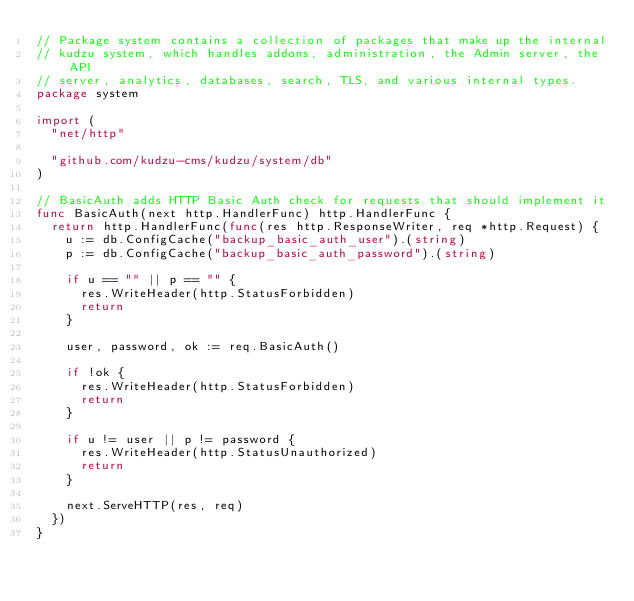Convert code to text. <code><loc_0><loc_0><loc_500><loc_500><_Go_>// Package system contains a collection of packages that make up the internal
// kudzu system, which handles addons, administration, the Admin server, the API
// server, analytics, databases, search, TLS, and various internal types.
package system

import (
	"net/http"

	"github.com/kudzu-cms/kudzu/system/db"
)

// BasicAuth adds HTTP Basic Auth check for requests that should implement it
func BasicAuth(next http.HandlerFunc) http.HandlerFunc {
	return http.HandlerFunc(func(res http.ResponseWriter, req *http.Request) {
		u := db.ConfigCache("backup_basic_auth_user").(string)
		p := db.ConfigCache("backup_basic_auth_password").(string)

		if u == "" || p == "" {
			res.WriteHeader(http.StatusForbidden)
			return
		}

		user, password, ok := req.BasicAuth()

		if !ok {
			res.WriteHeader(http.StatusForbidden)
			return
		}

		if u != user || p != password {
			res.WriteHeader(http.StatusUnauthorized)
			return
		}

		next.ServeHTTP(res, req)
	})
}
</code> 